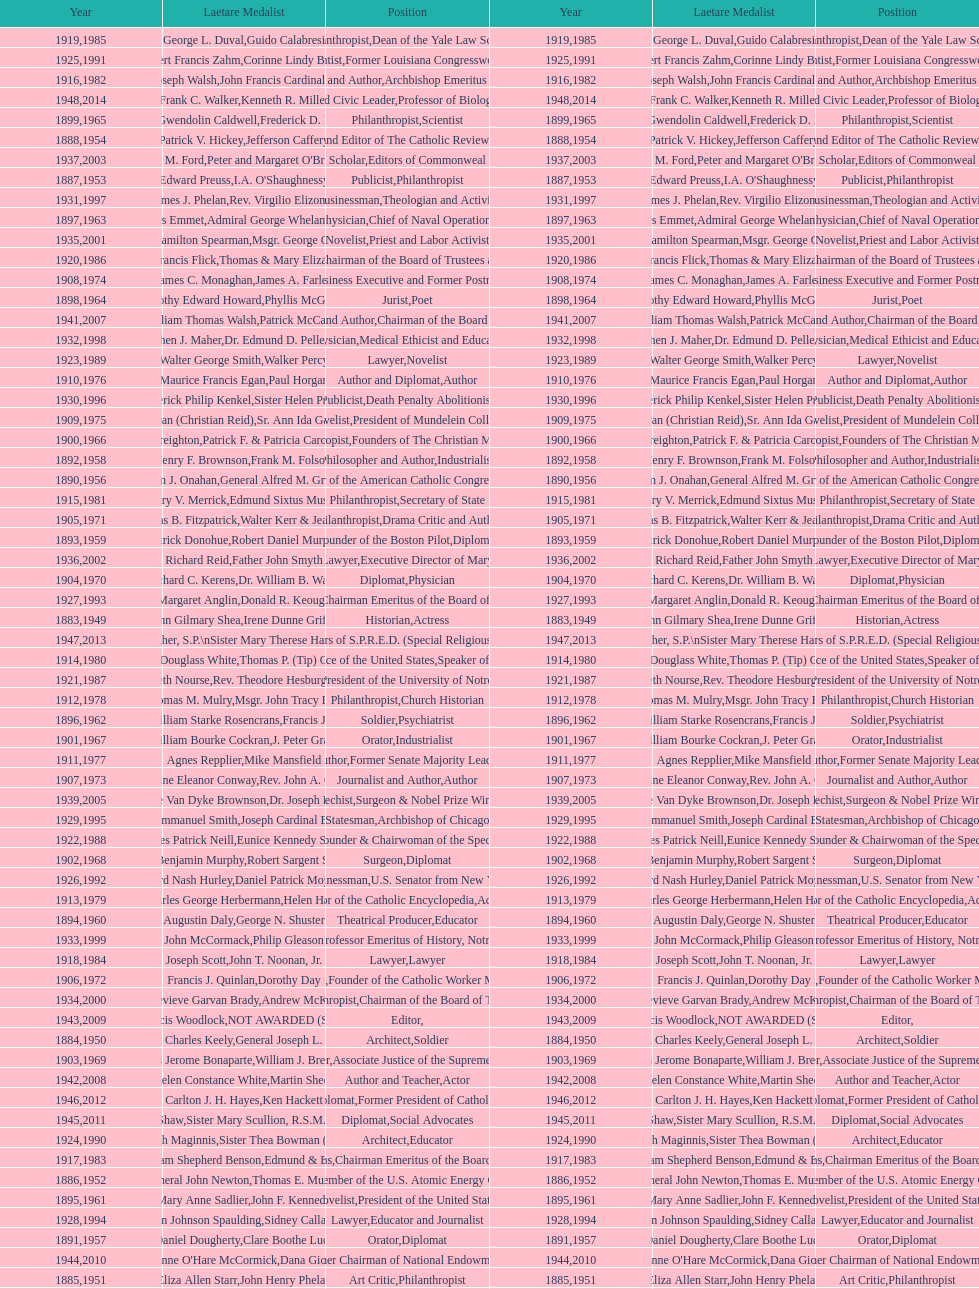What is the name of the laetare medalist mentioned before edward preuss? General John Newton. 